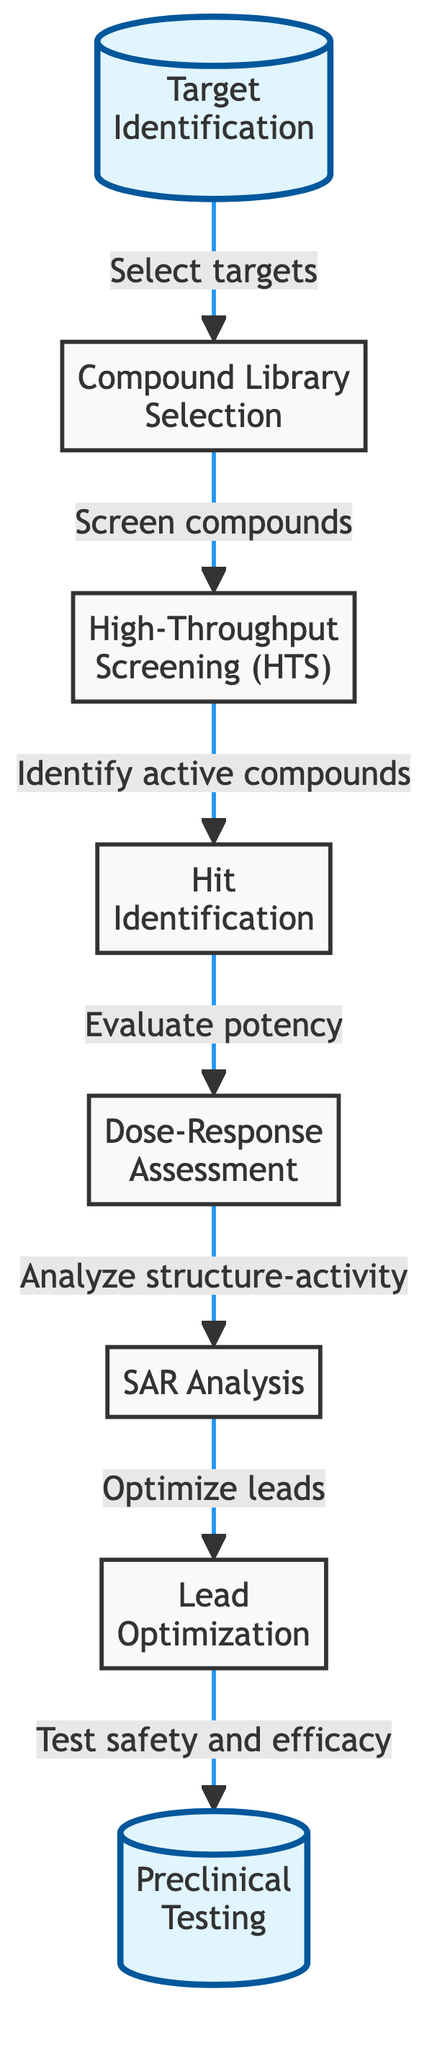What is the starting point of the workflow? The workflow begins with the "Target Identification" node, which is represented as the first step in the diagram.
Answer: Target Identification How many total nodes are there in the diagram? By counting all nodes represented in the flow chart, we find there are a total of 8 nodes.
Answer: 8 Which node comes immediately after Hit Identification? The node that follows "Hit Identification" is "Dose-Response Assessment." This is determined by tracing the arrow connecting those two nodes.
Answer: Dose-Response Assessment What is the final step in this screening workflow? The last step indicated by the flow chart is "Preclinical Testing." This can be confirmed by examining the last node in the sequence.
Answer: Preclinical Testing Which step evaluates the potency of identified hits? "Dose-Response Assessment" is responsible for evaluating potency, as indicated by the arrow leading to this node from "Hit Identification."
Answer: Dose-Response Assessment How many connections (edges) are present in the diagram? The diagram illustrates 7 connections between nodes, as each step flows seamlessly into the next, forming a linear sequence.
Answer: 7 What is the role of the "SAR Analysis" node? "SAR Analysis," or Structure-Activity Relationship Analysis, is the step where the relationship between chemical structure and biological activity is evaluated. It follows the "Dose-Response Assessment."
Answer: Analyze structure-activity What action leads to the optimization of leads? The process that leads to "Lead Optimization" is the analysis conducted in the "SAR Analysis" step, where insights are gathered to modify the chemical structure.
Answer: Analyze structure-activity 